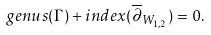Convert formula to latex. <formula><loc_0><loc_0><loc_500><loc_500>g e n u s ( \Gamma ) + i n d e x ( \overline { \partial } _ { W _ { 1 , 2 } } ) = 0 .</formula> 